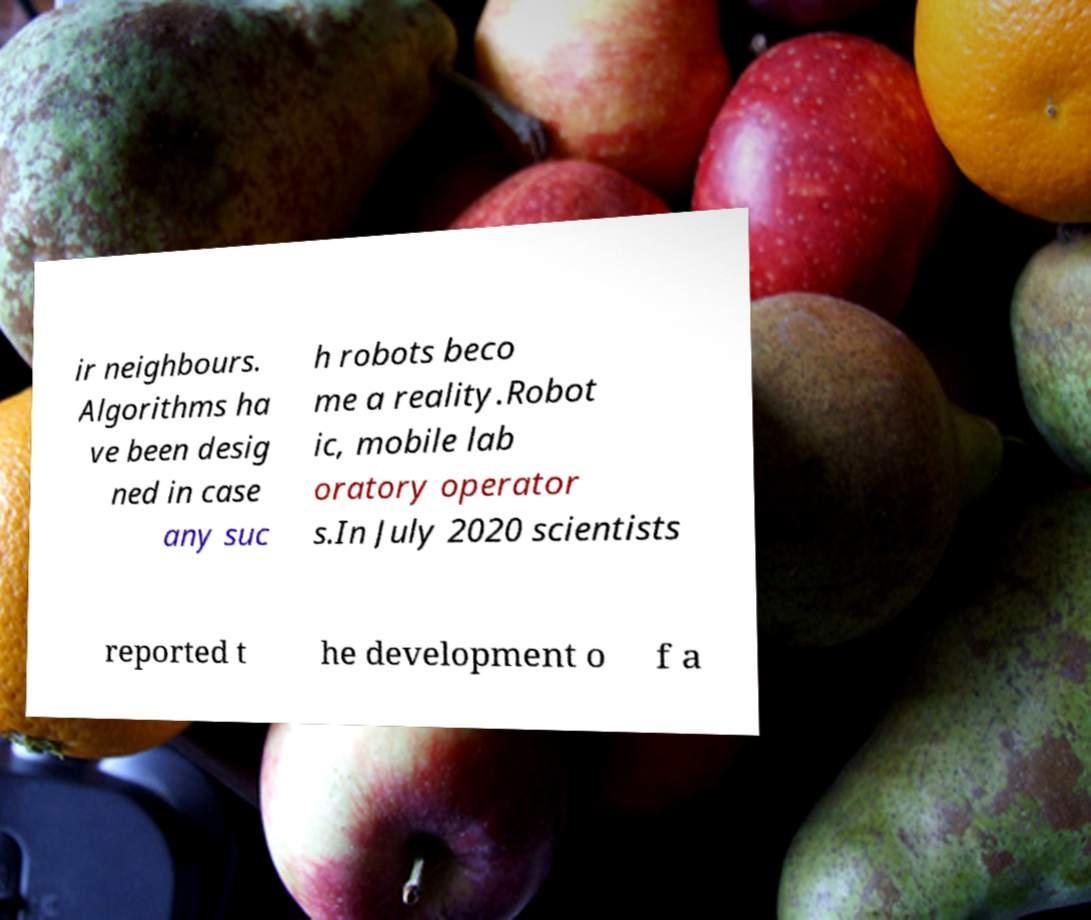Can you read and provide the text displayed in the image?This photo seems to have some interesting text. Can you extract and type it out for me? ir neighbours. Algorithms ha ve been desig ned in case any suc h robots beco me a reality.Robot ic, mobile lab oratory operator s.In July 2020 scientists reported t he development o f a 